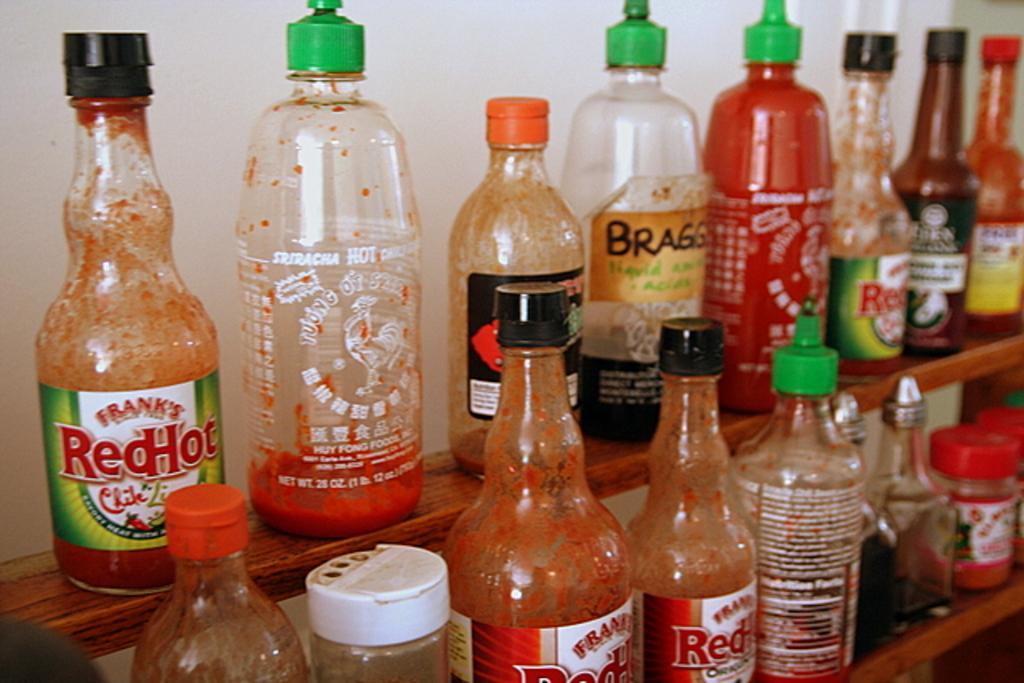Provide a one-sentence caption for the provided image. selection of hot sauce including Frank's Red Hot. 